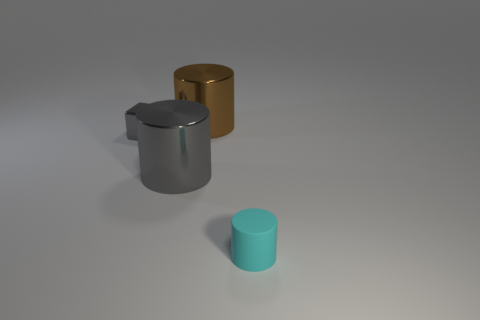Add 4 gray cylinders. How many objects exist? 8 Subtract all big gray cylinders. How many cylinders are left? 2 Subtract all cyan cylinders. How many cylinders are left? 2 Subtract 1 cylinders. How many cylinders are left? 2 Add 3 large gray shiny cubes. How many large gray shiny cubes exist? 3 Subtract 0 blue balls. How many objects are left? 4 Subtract all cylinders. How many objects are left? 1 Subtract all brown cylinders. Subtract all brown blocks. How many cylinders are left? 2 Subtract all small cyan objects. Subtract all tiny gray blocks. How many objects are left? 2 Add 4 cylinders. How many cylinders are left? 7 